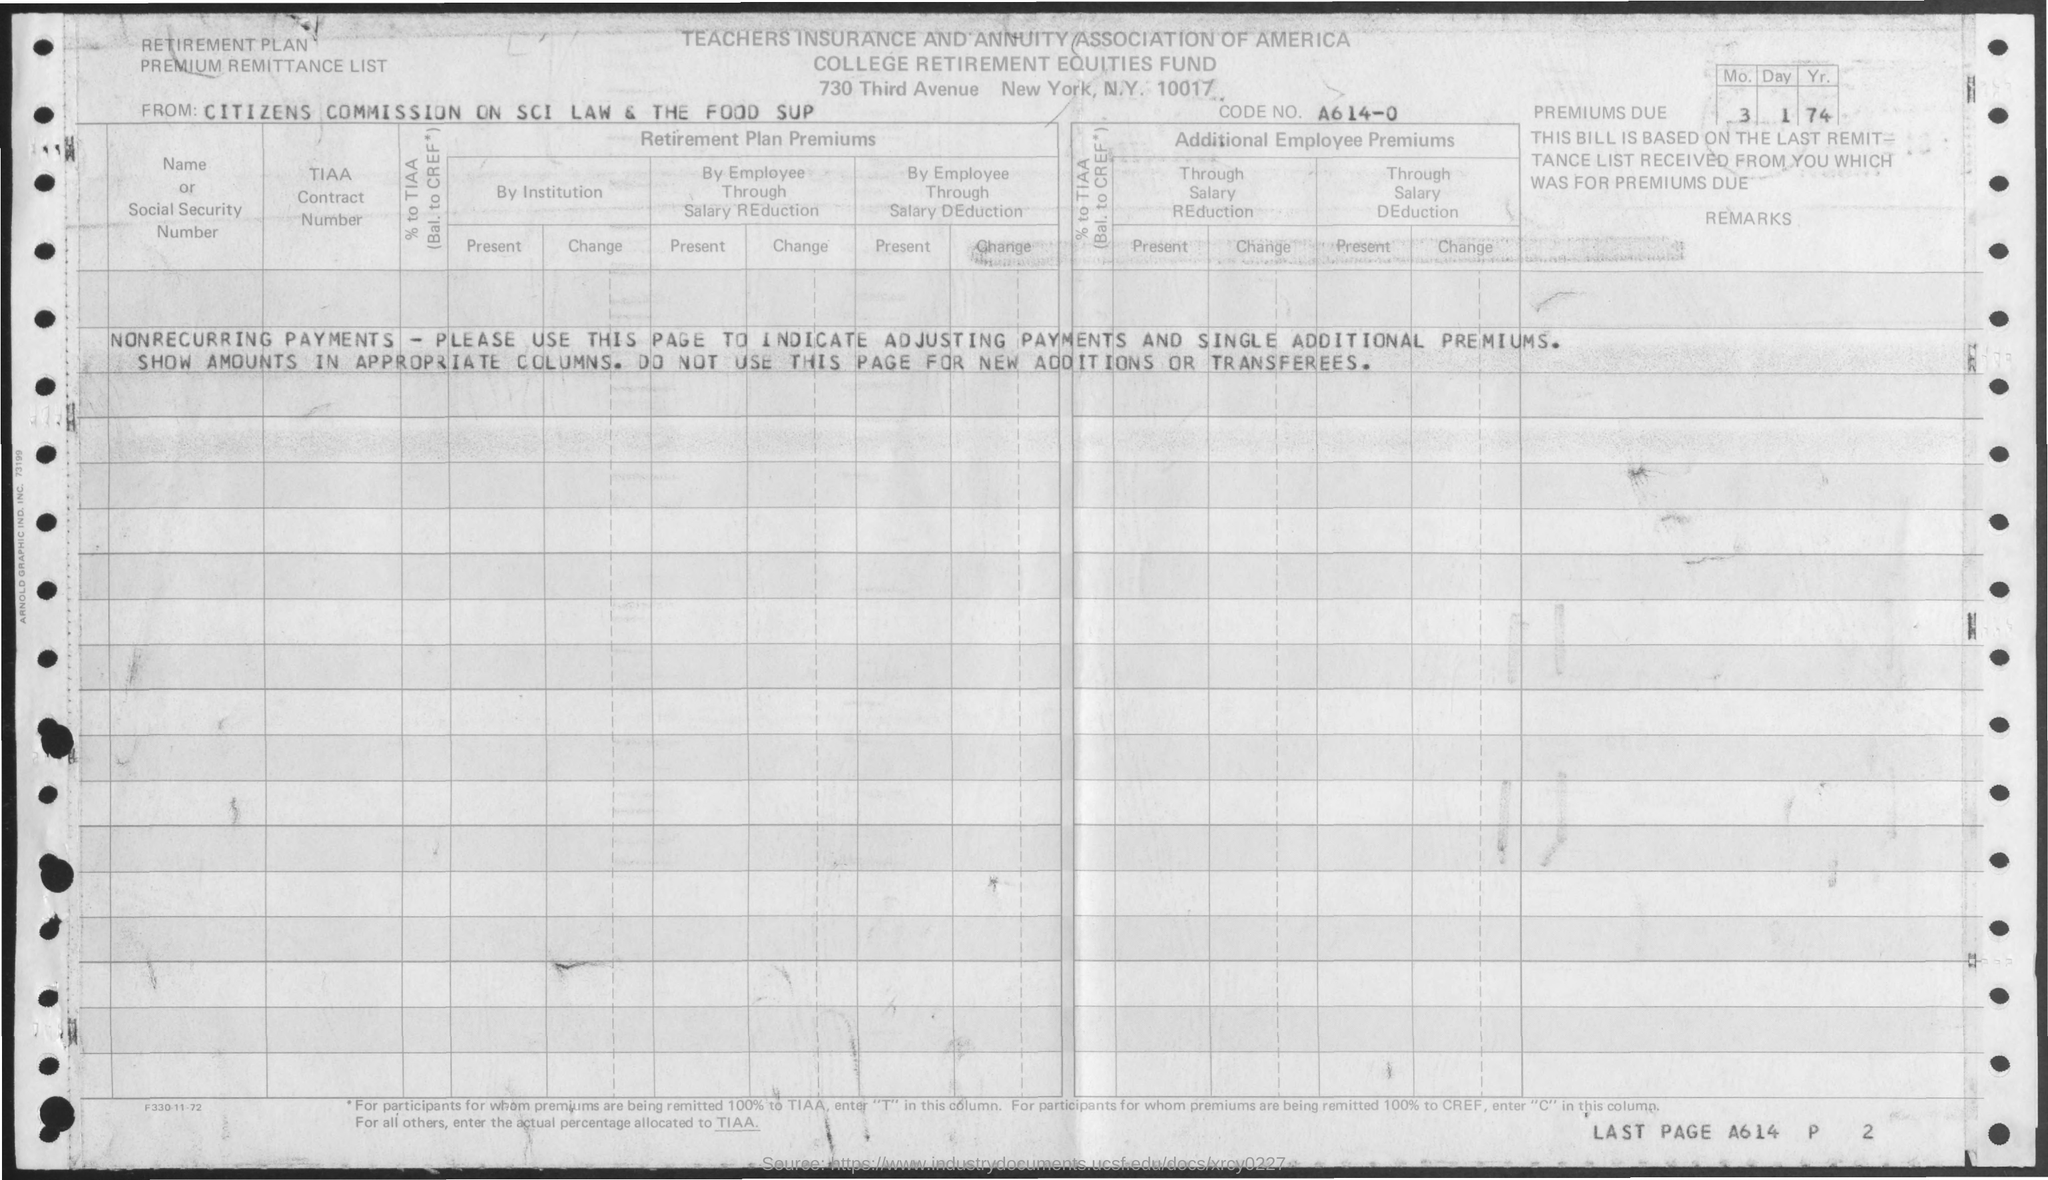Identify some key points in this picture. What is the code number? The association mentioned is Teachers Insurance and Annuity Association of America. 